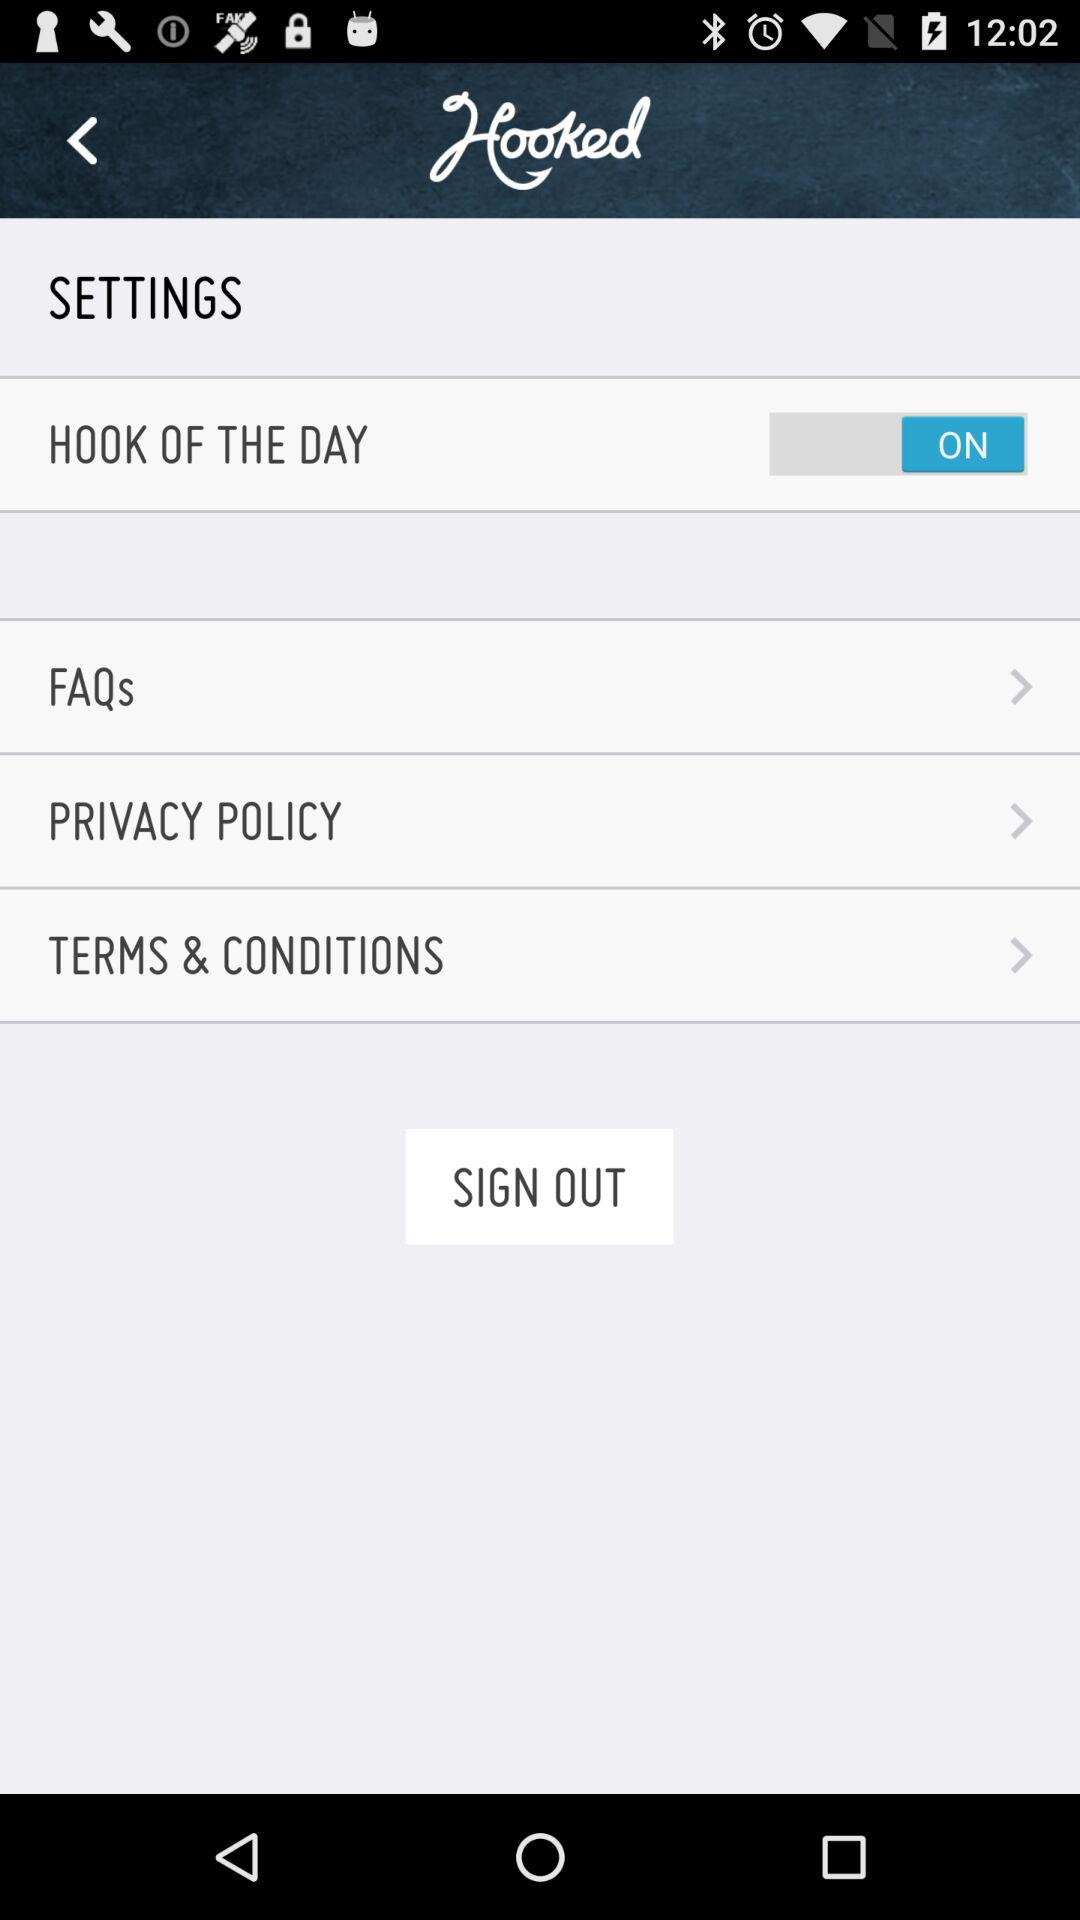What is the application name? The application name is "Hooked". 